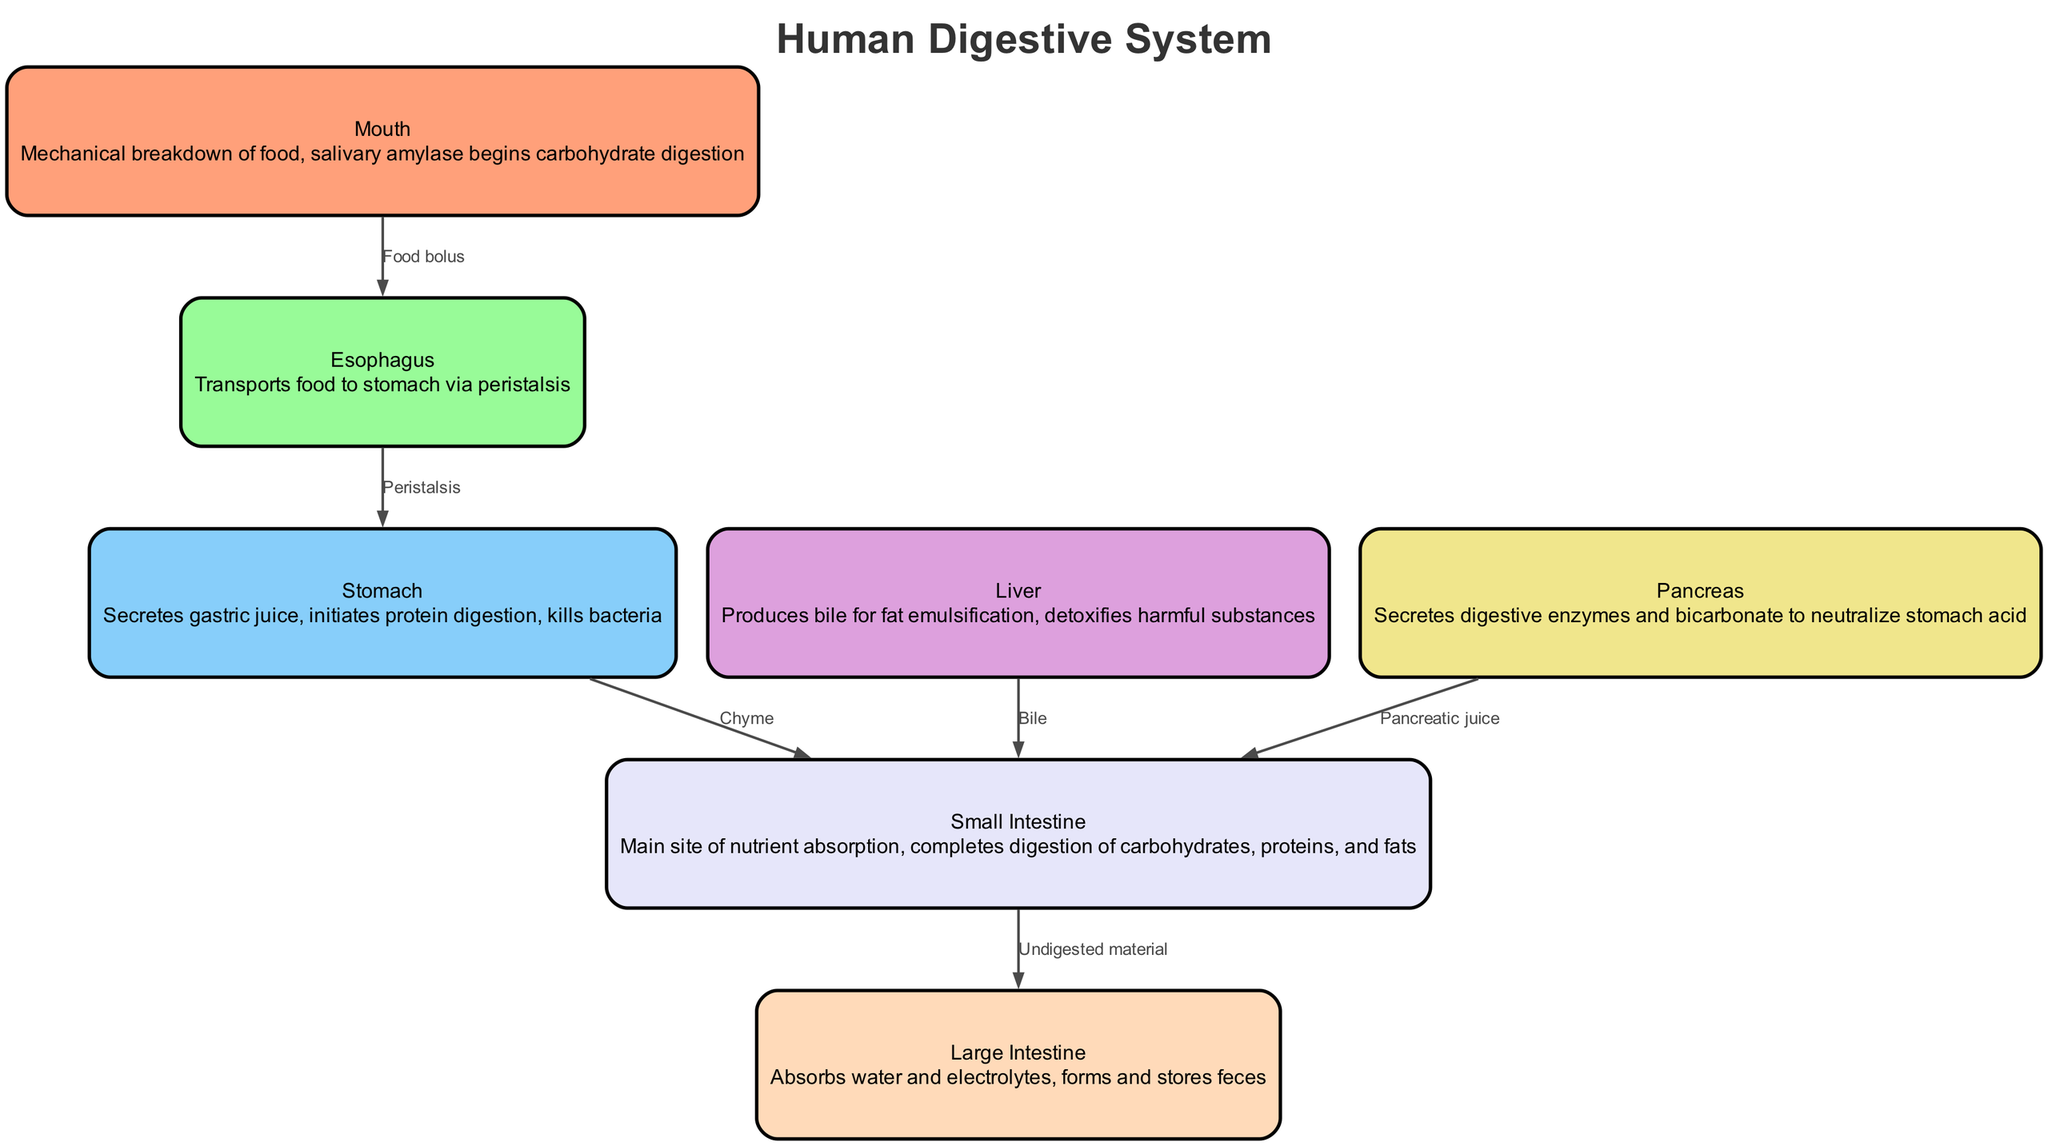What organ initiates protein digestion? The diagram indicates the stomach is labeled with the description "initiates protein digestion." This clearly shows that the function of the stomach involves the beginning of protein breakdown in the digestive process.
Answer: Stomach What substance is produced by the liver for fat emulsification? The relationship between the liver and the small intestine indicates that the liver produces bile, which is specifically mentioned in the diagram for the purpose of fat emulsification.
Answer: Bile How many nodes are represented in the diagram? By counting the distinct organs listed in the nodes section of the diagram, there are a total of seven: mouth, esophagus, stomach, liver, pancreas, small intestine, and large intestine.
Answer: Seven What transports food from the mouth to the stomach? The edge labeled "Peristalsis" directly connects the esophagus to the stomach, indicating that peristalsis is the movement responsible for transporting food from the mouth through the esophagus to the stomach.
Answer: Peristalsis What is the main site of nutrient absorption? The description associated with the small intestine clearly states that it is the main site for nutrient absorption, as indicated in the diagram.
Answer: Small intestine How does pancreatic juice reach the small intestine? The diagram shows a direct edge from the pancreas to the small intestine labeled "Pancreatic juice," indicating that digestive enzymes and bicarbonate are secreted by the pancreas and transported directly to the small intestine.
Answer: Pancreatic juice What does the large intestine do? The description associated with the large intestine states that it "absorbs water and electrolytes, forms and stores feces," summarizing its primary functions as shown in the diagram.
Answer: Absorbs water and stores feces What is the flow of undigested material? The edge from the small intestine to the large intestine is labeled "Undigested material," which illustrates that the remaining material after digestion is passed to the large intestine for further processing.
Answer: Undigested material What action is described as occurring in the esophagus? The labeled action "transports food to stomach via peristalsis" in the description of the esophagus outlines the function of moving the food to the stomach utilizing peristaltic movements.
Answer: Transports food via peristalsis 